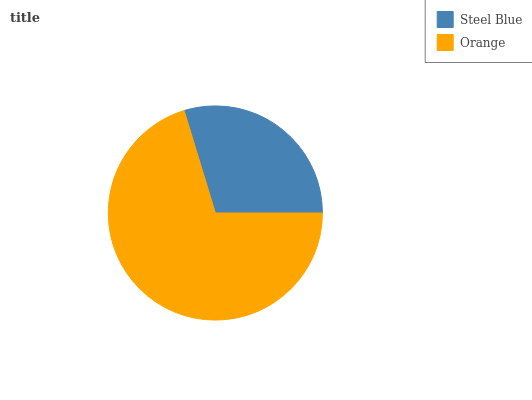Is Steel Blue the minimum?
Answer yes or no. Yes. Is Orange the maximum?
Answer yes or no. Yes. Is Orange the minimum?
Answer yes or no. No. Is Orange greater than Steel Blue?
Answer yes or no. Yes. Is Steel Blue less than Orange?
Answer yes or no. Yes. Is Steel Blue greater than Orange?
Answer yes or no. No. Is Orange less than Steel Blue?
Answer yes or no. No. Is Orange the high median?
Answer yes or no. Yes. Is Steel Blue the low median?
Answer yes or no. Yes. Is Steel Blue the high median?
Answer yes or no. No. Is Orange the low median?
Answer yes or no. No. 